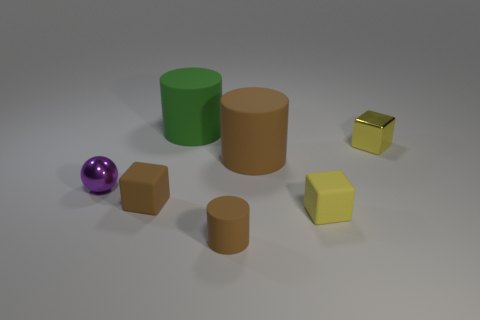Which of these objects could fit inside each other? Based on the apparent sizes, the green cylinder could potentially fit inside the larger brown cylinder as it appears to have a smaller diameter. The cubes, given their solid shape, would not be able to fit inside any of the cylinders, and neither the cylinders nor the cubes could enclose the ball due to its spherical shape. 